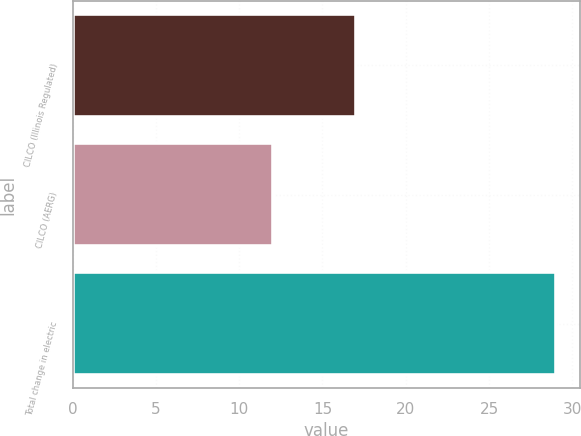Convert chart. <chart><loc_0><loc_0><loc_500><loc_500><bar_chart><fcel>CILCO (Illinois Regulated)<fcel>CILCO (AERG)<fcel>Total change in electric<nl><fcel>17<fcel>12<fcel>29<nl></chart> 